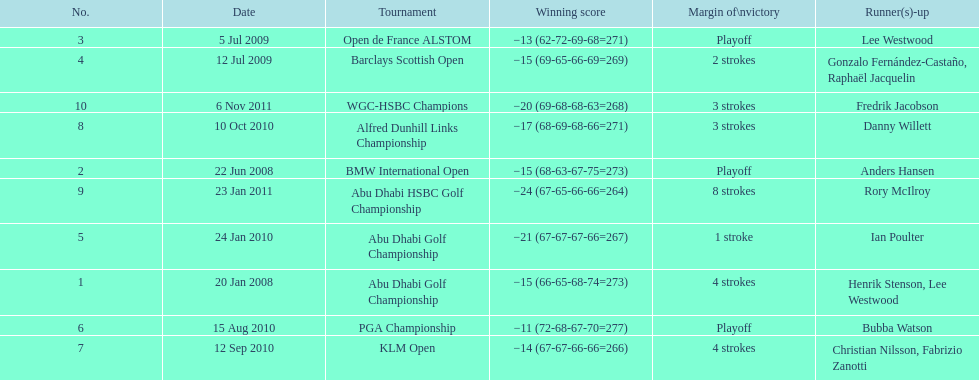Can you parse all the data within this table? {'header': ['No.', 'Date', 'Tournament', 'Winning score', 'Margin of\\nvictory', 'Runner(s)-up'], 'rows': [['3', '5 Jul 2009', 'Open de France ALSTOM', '−13 (62-72-69-68=271)', 'Playoff', 'Lee Westwood'], ['4', '12 Jul 2009', 'Barclays Scottish Open', '−15 (69-65-66-69=269)', '2 strokes', 'Gonzalo Fernández-Castaño, Raphaël Jacquelin'], ['10', '6 Nov 2011', 'WGC-HSBC Champions', '−20 (69-68-68-63=268)', '3 strokes', 'Fredrik Jacobson'], ['8', '10 Oct 2010', 'Alfred Dunhill Links Championship', '−17 (68-69-68-66=271)', '3 strokes', 'Danny Willett'], ['2', '22 Jun 2008', 'BMW International Open', '−15 (68-63-67-75=273)', 'Playoff', 'Anders Hansen'], ['9', '23 Jan 2011', 'Abu Dhabi HSBC Golf Championship', '−24 (67-65-66-66=264)', '8 strokes', 'Rory McIlroy'], ['5', '24 Jan 2010', 'Abu Dhabi Golf Championship', '−21 (67-67-67-66=267)', '1 stroke', 'Ian Poulter'], ['1', '20 Jan 2008', 'Abu Dhabi Golf Championship', '−15 (66-65-68-74=273)', '4 strokes', 'Henrik Stenson, Lee Westwood'], ['6', '15 Aug 2010', 'PGA Championship', '−11 (72-68-67-70=277)', 'Playoff', 'Bubba Watson'], ['7', '12 Sep 2010', 'KLM Open', '−14 (67-67-66-66=266)', '4 strokes', 'Christian Nilsson, Fabrizio Zanotti']]} Who achieved the highest score in the pga championship? Bubba Watson. 